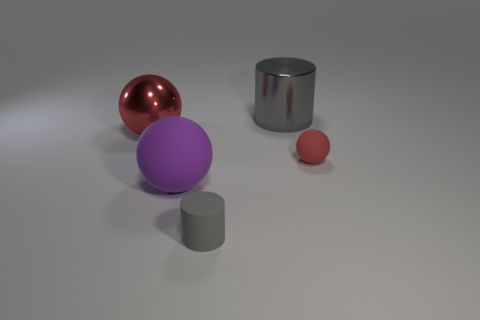How might the lighting in this room affect the appearance of the objects? The lighting in the room casts diffused shadows and creates soft reflections on the surfaces of the objects, giving the entire scene a calm and balanced ambience. The metallic objects reflect the light more brightly, which accentuates their smooth surfaces and contributes to the perception of their material qualities. 